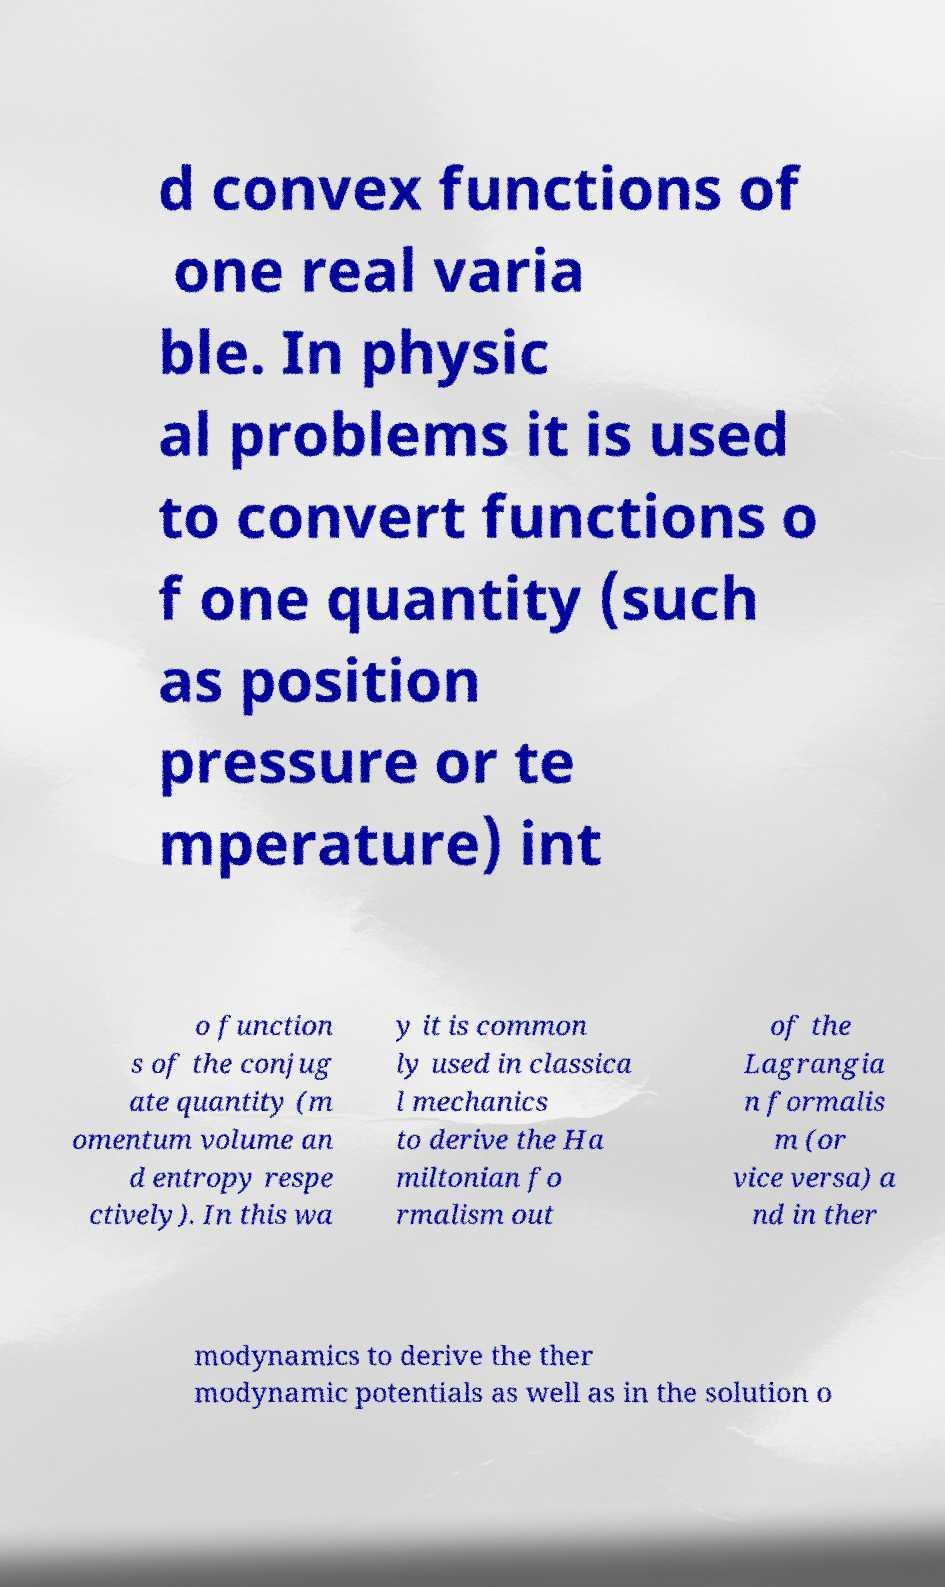There's text embedded in this image that I need extracted. Can you transcribe it verbatim? d convex functions of one real varia ble. In physic al problems it is used to convert functions o f one quantity (such as position pressure or te mperature) int o function s of the conjug ate quantity (m omentum volume an d entropy respe ctively). In this wa y it is common ly used in classica l mechanics to derive the Ha miltonian fo rmalism out of the Lagrangia n formalis m (or vice versa) a nd in ther modynamics to derive the ther modynamic potentials as well as in the solution o 